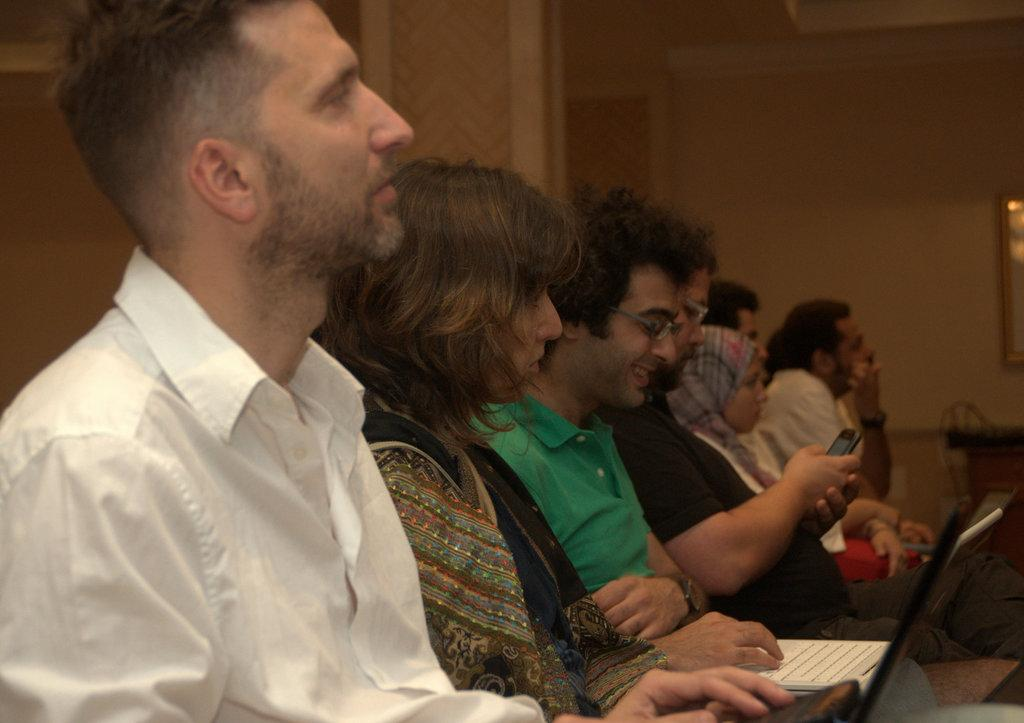How many people are in the image? There is a group of people in the image. What are the people doing in the image? The people are sitting on chairs and holding laptops and mobile phones. What can be seen in the background of the image? There is a photo frame, a pillar, and a wall in the background of the image. What type of badge is the person wearing in the image? There is no badge visible on any person in the image. What kind of pest can be seen crawling on the wall in the image? There are no pests visible on the wall or anywhere else in the image. 